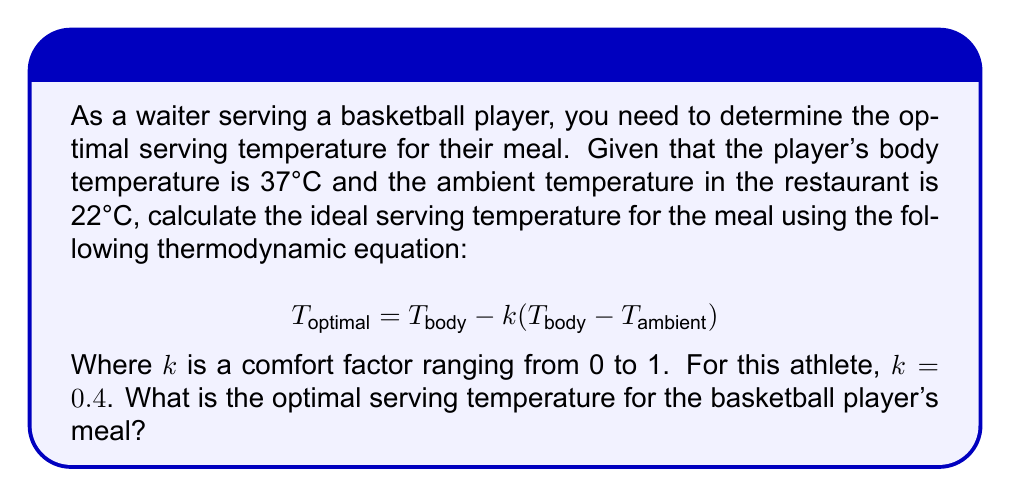Give your solution to this math problem. To solve this problem, we'll use the given thermodynamic equation and substitute the known values:

1. Given information:
   $T_{body} = 37°C$
   $T_{ambient} = 22°C$
   $k = 0.4$

2. Substitute these values into the equation:
   $$T_{optimal} = T_{body} - k(T_{body} - T_{ambient})$$
   $$T_{optimal} = 37 - 0.4(37 - 22)$$

3. Simplify the expression inside the parentheses:
   $$T_{optimal} = 37 - 0.4(15)$$

4. Multiply:
   $$T_{optimal} = 37 - 6$$

5. Calculate the final result:
   $$T_{optimal} = 31°C$$

Therefore, the optimal serving temperature for the basketball player's meal is 31°C.
Answer: 31°C 